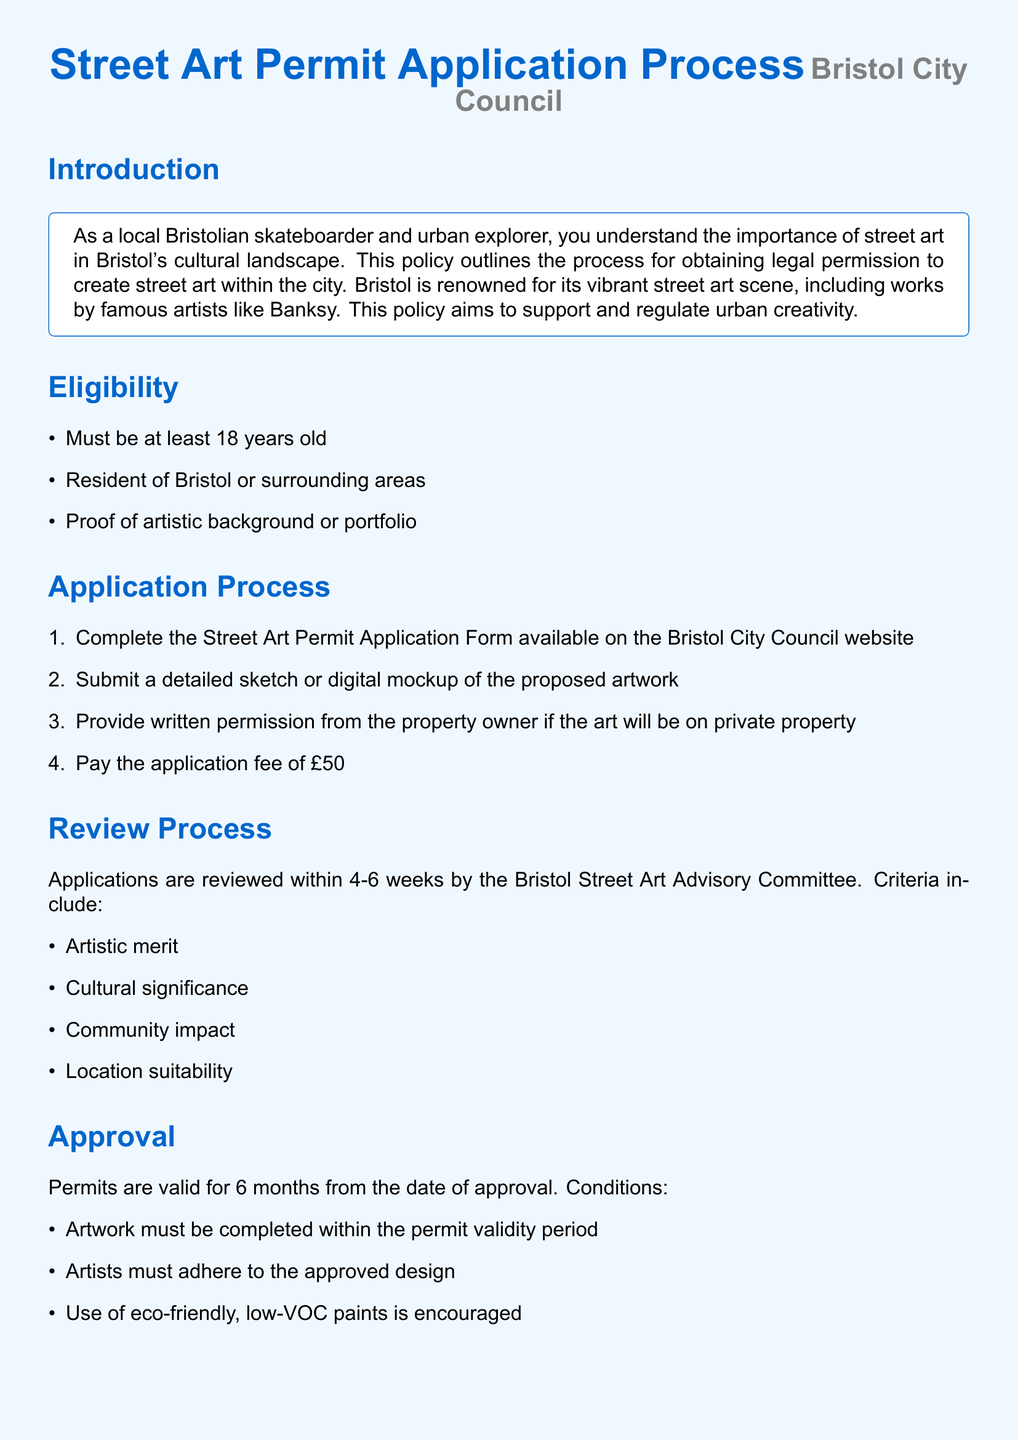What is the application fee for a street art permit? The document states that the application fee is mentioned clearly in the Application Process section.
Answer: £50 How long does the review process take? The timeline for the review process is provided in the Review Process section, indicating an expected duration.
Answer: 4-6 weeks What is the minimum age requirement to apply for a permit? The eligibility criteria specifically mention this age requirement in the Eligibility section of the document.
Answer: 18 years old Which email address can be used for inquiries about street art permits? The contact details section provides the email address for the Arts and Culture Department.
Answer: streetart@bristol.gov.uk What is one of the locations where street art is approved? The document lists specific approved locations in the Locations section.
Answer: Nelson Street What is the duration of validity for a street art permit? This duration is specified in the Approval section where the validity duration is mentioned.
Answer: 6 months What type of materials is encouraged for use in street art? The document encourages a specific characteristic of the materials to be used in the Approval section.
Answer: Eco-friendly, low-VOC paints What does the application process begin with? The first step of the application process is detailed in the Application Process section, indicating the necessary form.
Answer: Street Art Permit Application Form Which committee reviews the street art applications? The document specifies which committee is responsible for the review process in the Review Process section.
Answer: Bristol Street Art Advisory Committee 